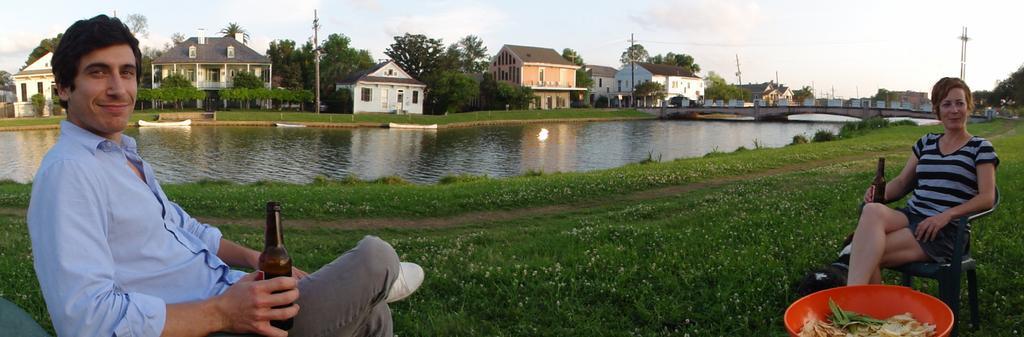How would you summarize this image in a sentence or two? This picture is taken outside. There are two persons, one woman in the right side, holding a bottle and another man, he is in left side and he is also holding a bottle. Between them there is a grass. In the center there is a lake. In the top there are buildings, trees and light sky. 